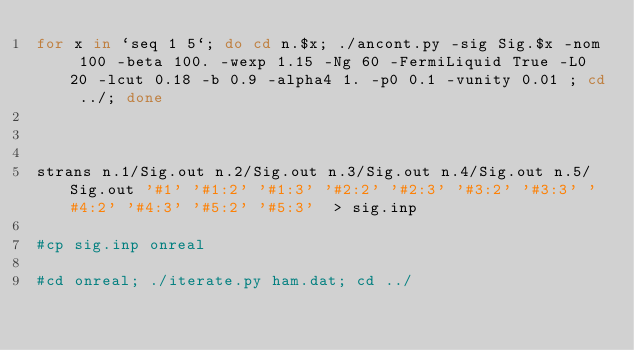Convert code to text. <code><loc_0><loc_0><loc_500><loc_500><_Bash_>for x in `seq 1 5`; do cd n.$x; ./ancont.py -sig Sig.$x -nom 100 -beta 100. -wexp 1.15 -Ng 60 -FermiLiquid True -L0 20 -lcut 0.18 -b 0.9 -alpha4 1. -p0 0.1 -vunity 0.01 ; cd ../; done



strans n.1/Sig.out n.2/Sig.out n.3/Sig.out n.4/Sig.out n.5/Sig.out '#1' '#1:2' '#1:3' '#2:2' '#2:3' '#3:2' '#3:3' '#4:2' '#4:3' '#5:2' '#5:3'  > sig.inp

#cp sig.inp onreal

#cd onreal; ./iterate.py ham.dat; cd ../
</code> 